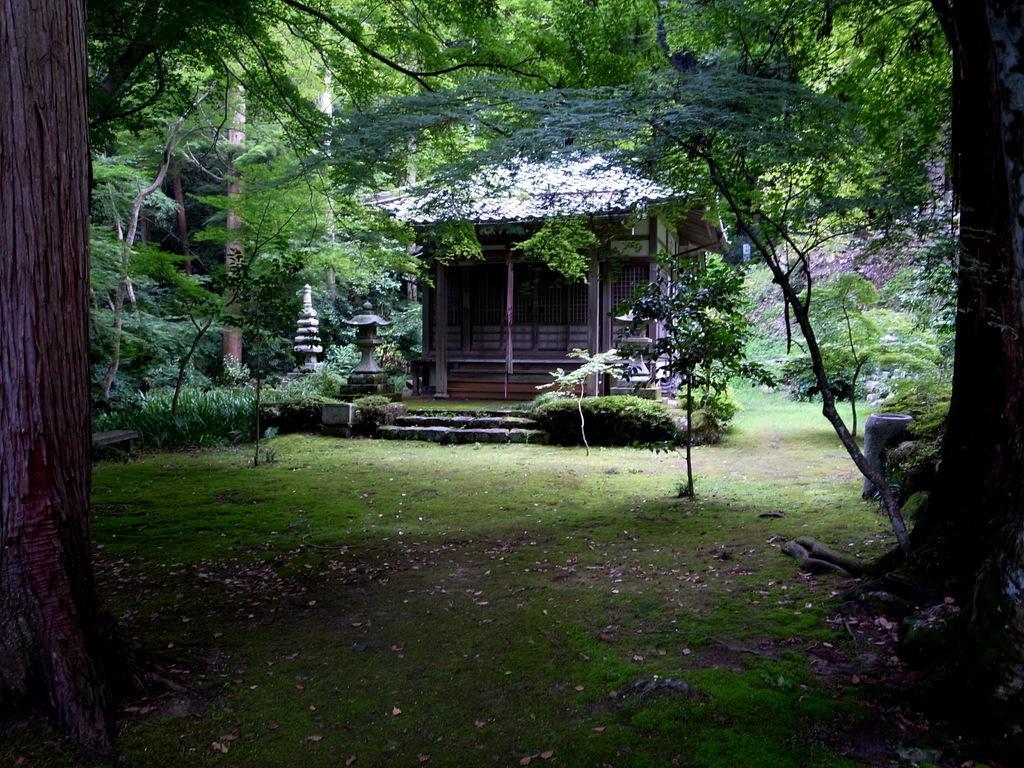Please provide a concise description of this image. In this picture we can see few trees and a house. 